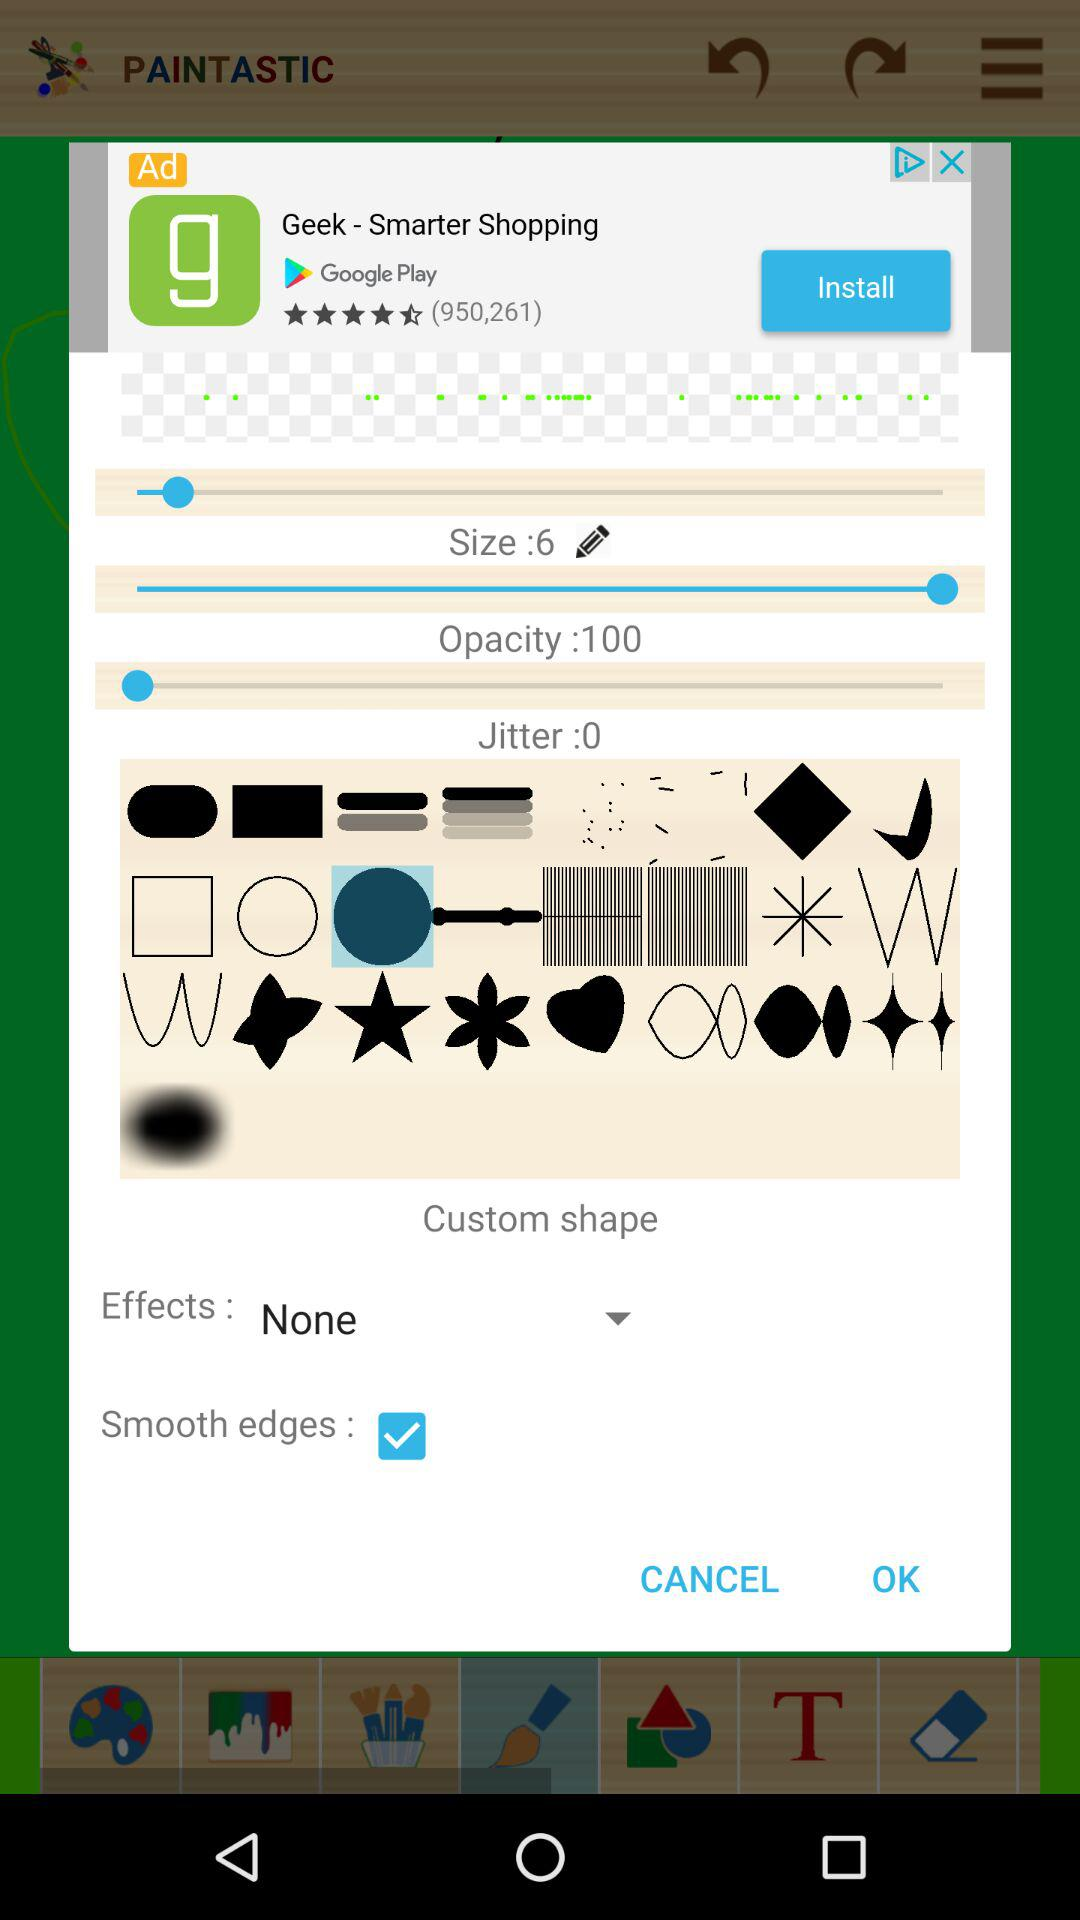What is the effect? The effect is "None". 